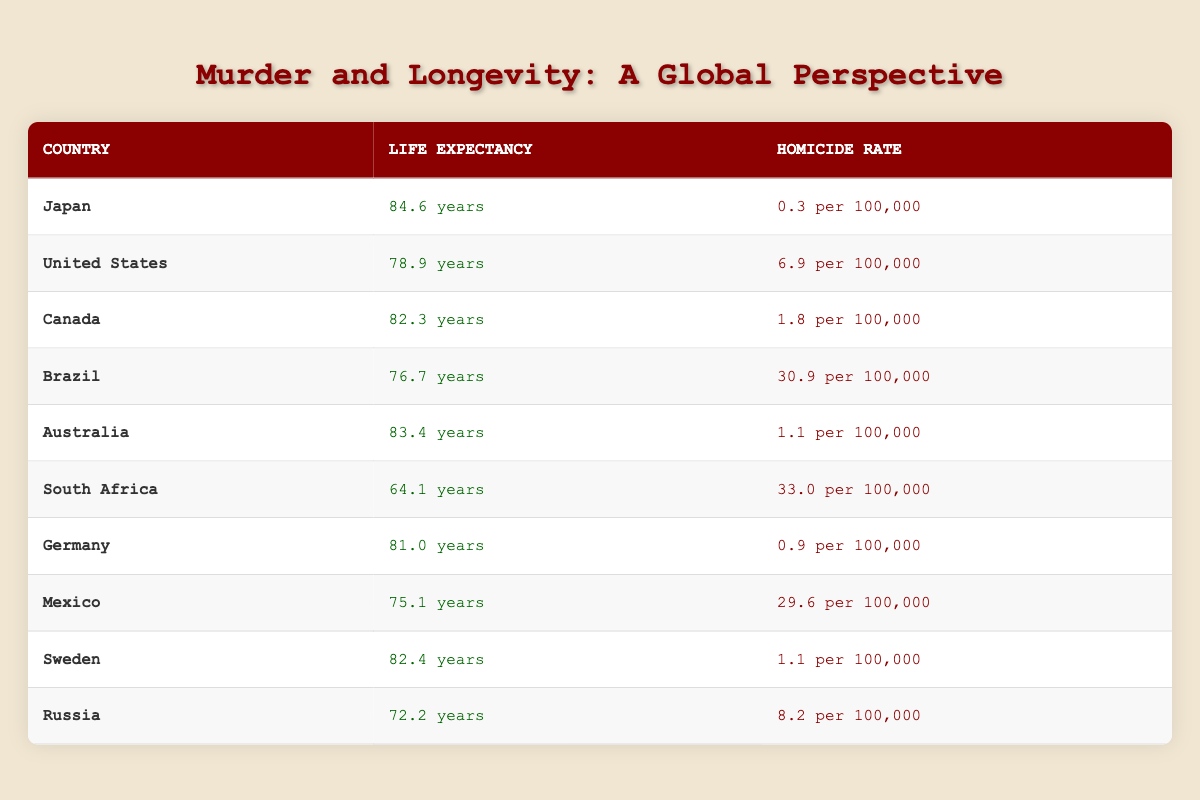What is the life expectancy in Japan? Japan is listed in the table with a life expectancy value of 84.6 years.
Answer: 84.6 years Which country has the highest homicide rate? The table shows Brazil with a homicide rate of 30.9 per 100,000, which is the highest among the listed countries.
Answer: Brazil What is the difference in life expectancy between South Africa and Germany? South Africa's life expectancy is 64.1 years and Germany's is 81.0 years. The difference is calculated as 81.0 - 64.1 = 16.9 years.
Answer: 16.9 years Is the life expectancy in Canada higher than that of the United States? Canada has a life expectancy of 82.3 years, while the United States has 78.9 years, so the statement is true.
Answer: Yes What is the average life expectancy of the ten countries listed? To find the average, we sum the life expectancies: 84.6 + 78.9 + 82.3 + 76.7 + 83.4 + 64.1 + 81.0 + 75.1 + 82.4 + 72.2 =  799.7. Dividing this by 10 gives the average: 799.7 / 10 = 79.97 years.
Answer: 79.97 years Is the homicide rate in Mexico higher than in Japan? Japan has a homicide rate of 0.3 per 100,000, while Mexico's is 29.6 per 100,000. Thus, the statement is true since 29.6 is greater than 0.3.
Answer: Yes Which country has the lowest life expectancy and what is that value? Referring to the table, South Africa has the lowest life expectancy of 64.1 years.
Answer: South Africa, 64.1 years If the homicide rates in Europe (Germany and Sweden) were combined, what would be their total? Germany's homicide rate is 0.9 and Sweden's is 1.1. The total is calculated as 0.9 + 1.1 = 2.0 per 100,000.
Answer: 2.0 per 100,000 How many countries have a life expectancy greater than 80 years? From the table, the countries with life expectancy greater than 80 are Japan (84.6), Canada (82.3), Australia (83.4), and Sweden (82.4). This amounts to 4 countries.
Answer: 4 countries 